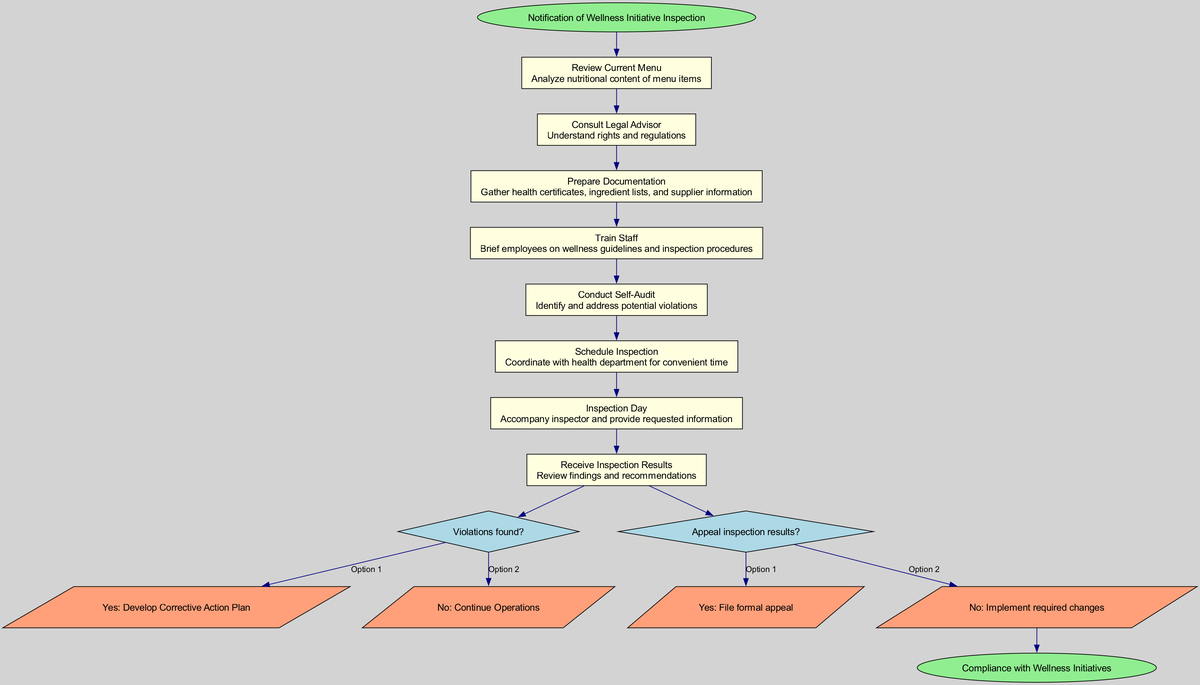What is the starting point of the pathway? The starting point is labeled as "Notification of Wellness Initiative Inspection." This is the first node in the diagram, marking the beginning of the clinical pathway.
Answer: Notification of Wellness Initiative Inspection How many steps are in the pathway? The diagram lists eight distinct steps leading up to the inspection decision points. This includes all the actions that need to be taken before reaching the decision points.
Answer: Eight What follows the 'Train Staff' step? The 'Conduct Self-Audit' step follows. According to the flow of the diagram, these steps are sequential, and 'Train Staff' leads directly to 'Conduct Self-Audit.'
Answer: Conduct Self-Audit What is the question asked at the first decision point? The first decision point asks, "Violations found?" This question is essential as it leads to different outcomes based on the result of the inspection.
Answer: Violations found? What is required if violations are found? If violations are found, the next required action is to "Develop Corrective Action Plan." This signifies that immediate steps must be taken to address any identified issues.
Answer: Develop Corrective Action Plan What are the two options after receiving inspection results? The options are "Yes: File formal appeal" and "No: Implement required changes." These reactions vary depending on how the franchisee decides to address the inspection outcome.
Answer: File formal appeal, Implement required changes Which two nodes lead to the endpoint? The endpoint "Compliance with Wellness Initiatives" is reached from the option "No: Implement required changes" following the second decision point. This shows the successful completion of the pathway.
Answer: No: Implement required changes What shape represents the decision points in the diagram? The decision points are represented by diamond shapes. This is a standard convention in flow diagrams to indicate points where decisions must be made.
Answer: Diamond What color are the nodes indicating steps in the pathway? The nodes indicating steps in the pathway are filled with light yellow. This color is consistent throughout the steps to signify actions to be taken.
Answer: Light yellow 